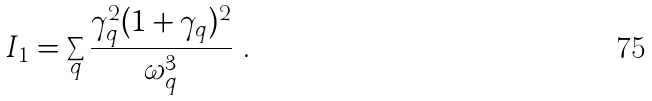<formula> <loc_0><loc_0><loc_500><loc_500>I _ { 1 } = \sum _ { q } \frac { \gamma _ { q } ^ { 2 } ( 1 + \gamma _ { q } ) ^ { 2 } } { \omega _ { q } ^ { 3 } } \ .</formula> 